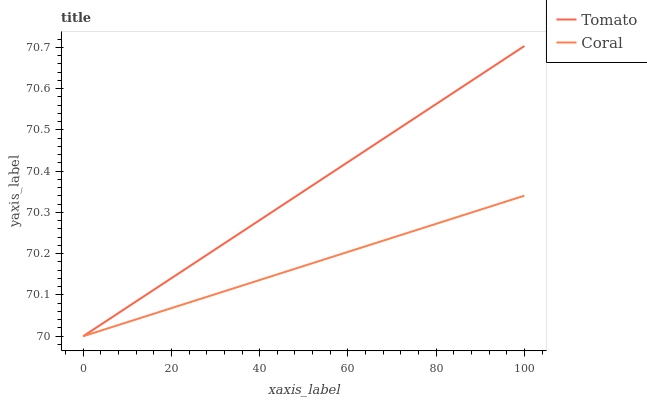Does Coral have the maximum area under the curve?
Answer yes or no. No. Is Coral the smoothest?
Answer yes or no. No. Does Coral have the highest value?
Answer yes or no. No. 